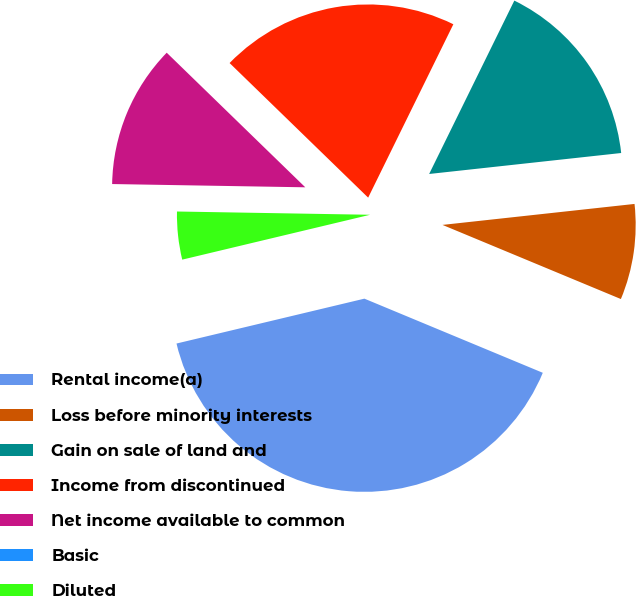<chart> <loc_0><loc_0><loc_500><loc_500><pie_chart><fcel>Rental income(a)<fcel>Loss before minority interests<fcel>Gain on sale of land and<fcel>Income from discontinued<fcel>Net income available to common<fcel>Basic<fcel>Diluted<nl><fcel>40.0%<fcel>8.0%<fcel>16.0%<fcel>20.0%<fcel>12.0%<fcel>0.0%<fcel>4.0%<nl></chart> 